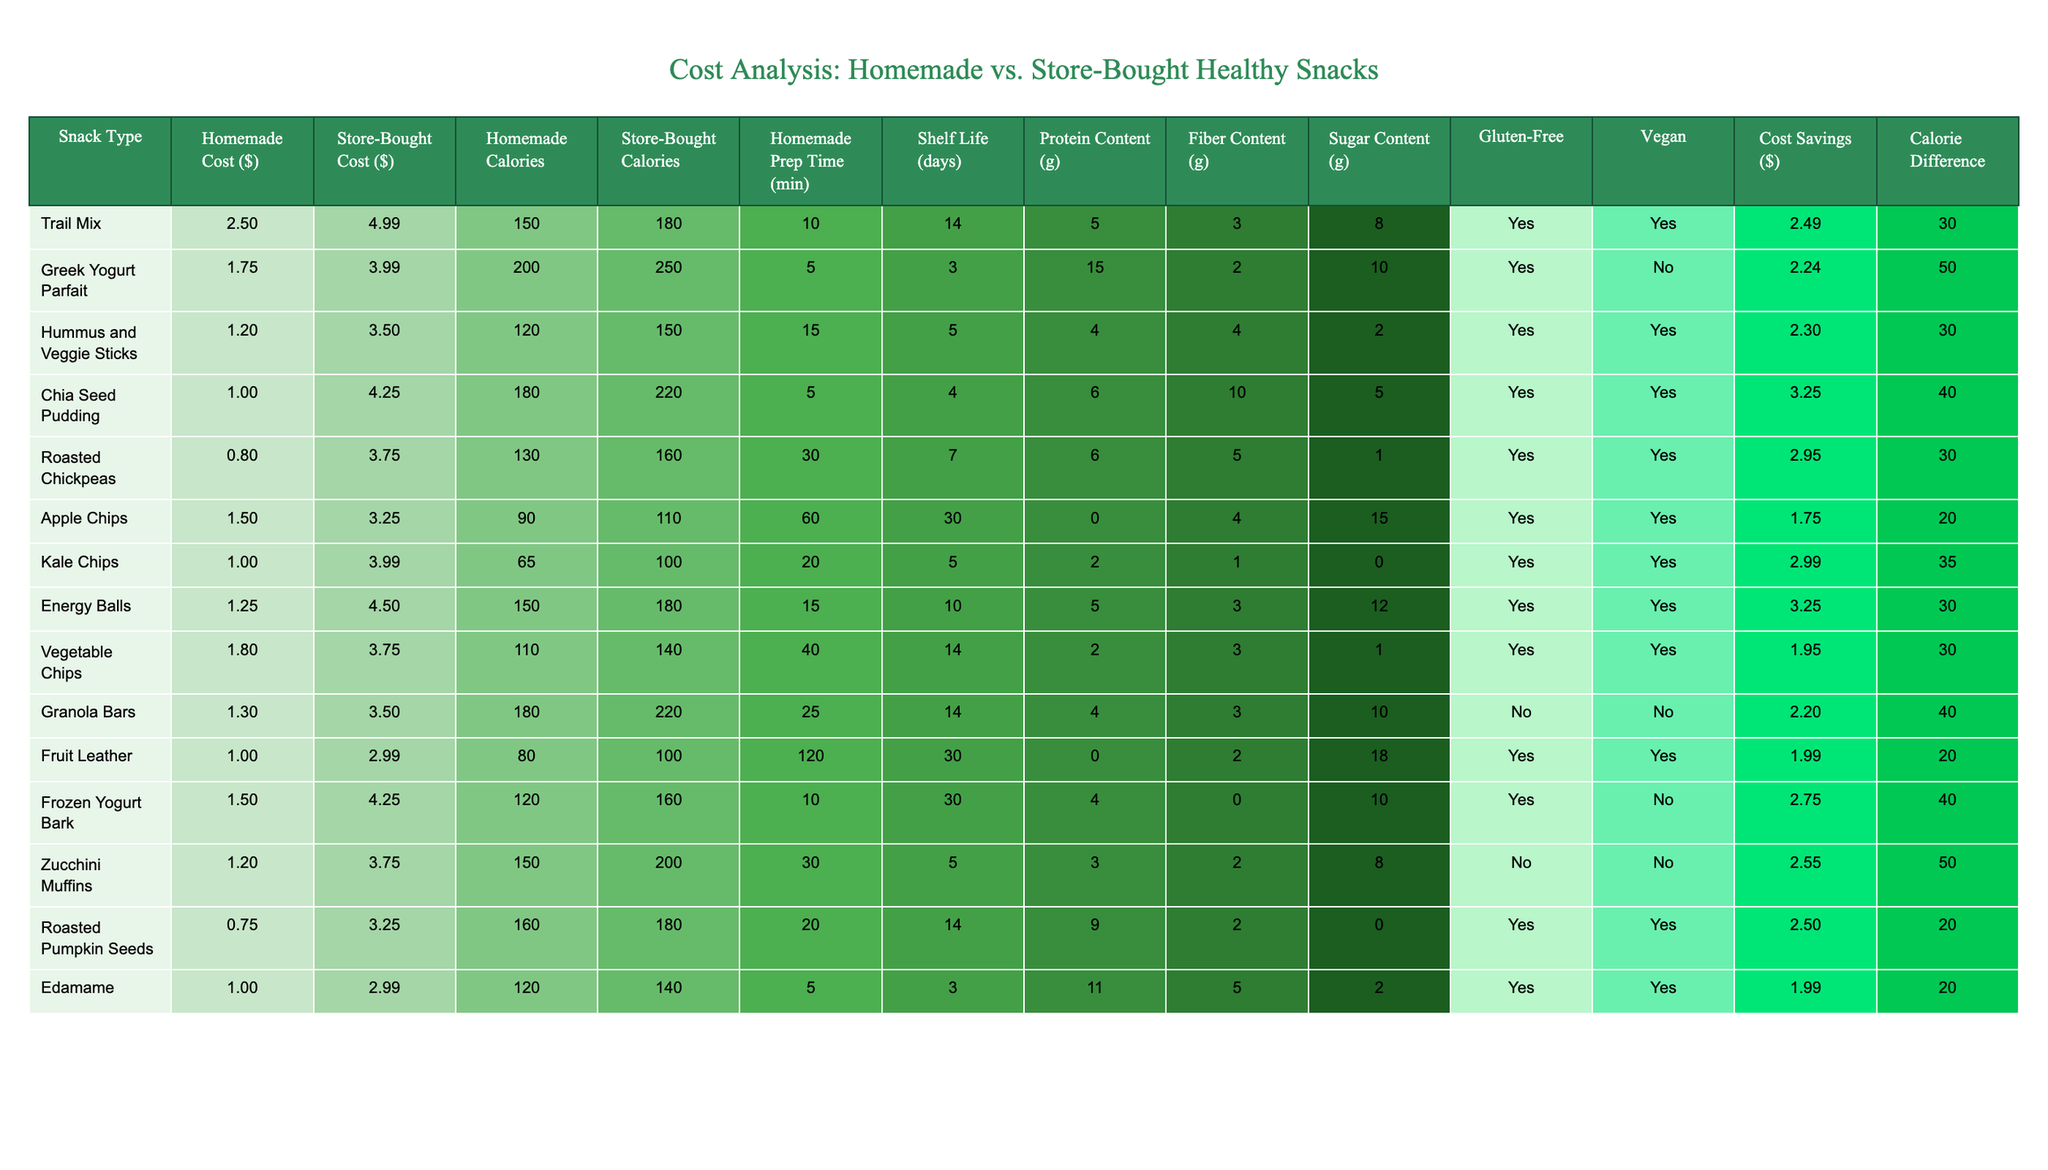What is the cost difference between homemade and store-bought Trail Mix? The cost of homemade Trail Mix is $2.50, while store-bought costs $4.99. The difference is calculated as $4.99 - $2.50 = $2.49.
Answer: $2.49 Which homemade snack has the highest protein content? Reviewing the protein content, the Greek Yogurt Parfait has 15g of protein, which is higher compared to the other snacks listed.
Answer: Greek Yogurt Parfait What is the average preparation time for all homemade snacks? Adding all homemade prep times gives us 10 + 5 + 15 + 5 + 30 + 60 + 20 + 15 + 25 + 120 + 10 + 30 + 30 = 335 minutes. There are 13 snacks, so the average prep time is 335 / 13 = 25.77 minutes.
Answer: 25.77 minutes Is Fruit Leather gluten-free? The table indicates that Fruit Leather is marked as "Yes" under the Gluten-Free column.
Answer: Yes How much money can be saved by choosing homemade Roasted Chickpeas over store-bought? The homemade cost for Roasted Chickpeas is $0.80 and the store-bought price is $3.75. The savings can be calculated as $3.75 - $0.80 = $2.95.
Answer: $2.95 Which snack has the longest shelf life among the homemade options? The shelf life of each homemade snack is compared, and we find that Apple Chips have the longest at 30 days.
Answer: Apple Chips What is the total calorie difference for all snacks comparing homemade to store-bought? From the table, we calculate the calorie differences: (180 - 150) + (250 - 200) + (150 - 120) + (220 - 180) + (160 - 130) + (110 - 90) + (100 - 65) + (180 - 150) + (140 - 110) + (220 - 180) + (100 - 80) + (160 - 120) + (200 - 150) = 30 + 50 + 30 + 40 + 30 + 20 + 35 + 30 + 30 + 40 + 20 + 40 + 50 = 470 calories.
Answer: 470 calories Are Kale Chips vegan? The table lists Kale Chips as "Yes" under the Vegan column, confirming they are vegan.
Answer: Yes What is the sugar content of the homemade Energy Balls? From the table, it is clear that the homemade Energy Balls have a sugar content of 12g.
Answer: 12g If someone is looking for a snack that is both vegan and gluten-free, which would be the best option? Hummus and Veggie Sticks is marked as both vegan and gluten-free in the table, making it the best option for those preferences.
Answer: Hummus and Veggie Sticks 